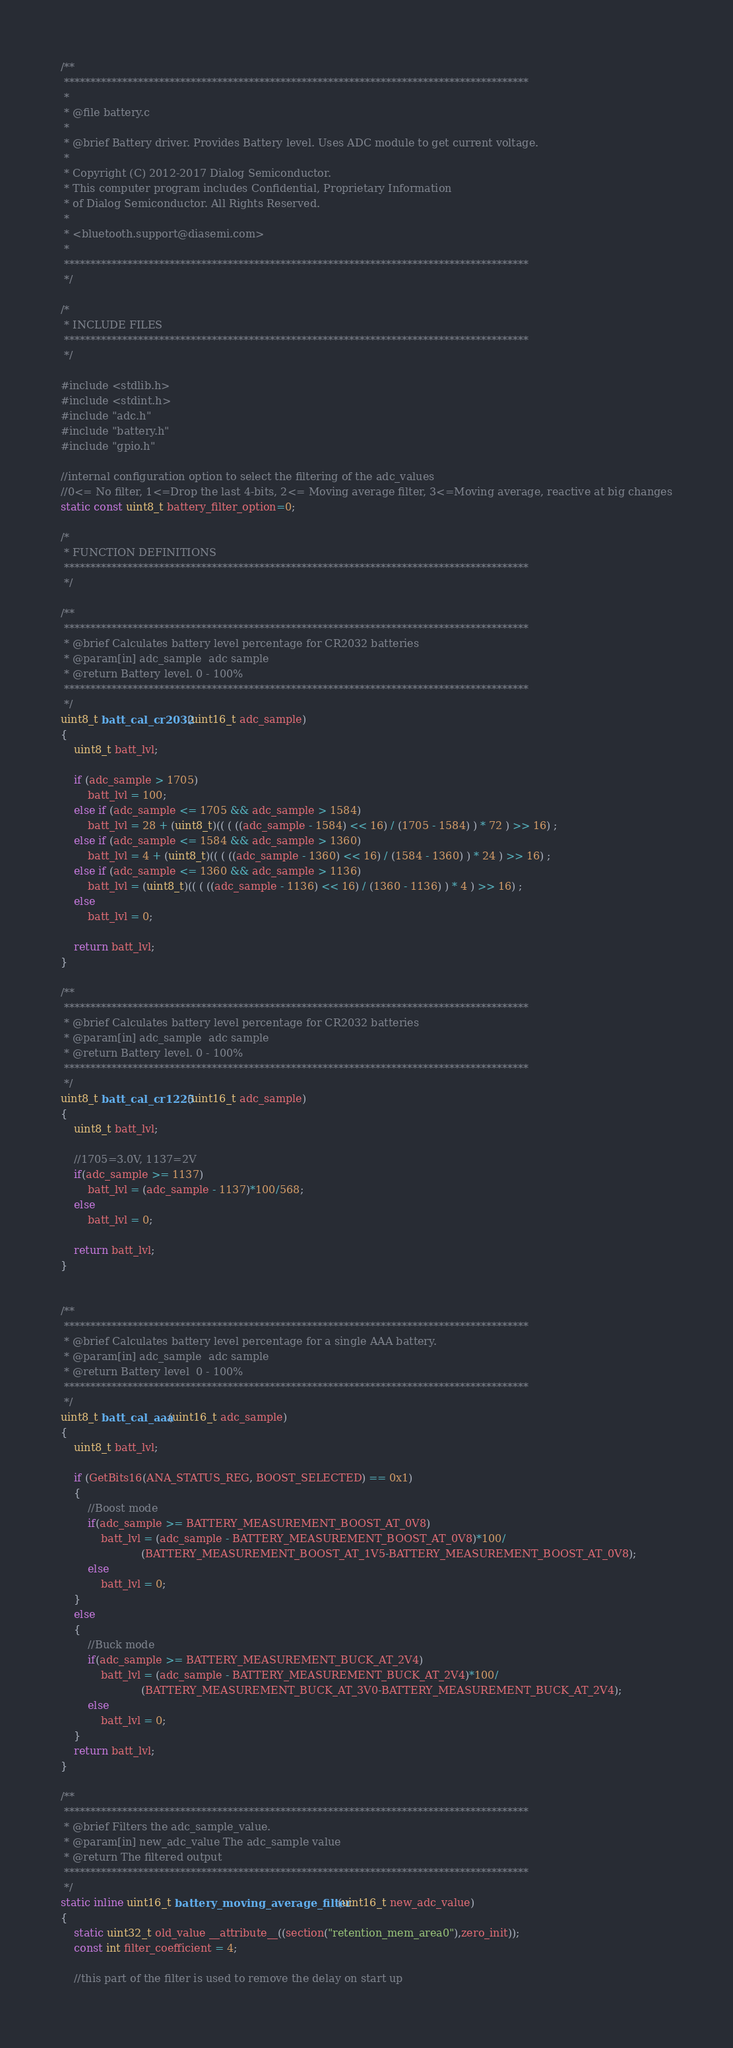<code> <loc_0><loc_0><loc_500><loc_500><_C_>/**
 ****************************************************************************************
 *
 * @file battery.c
 *
 * @brief Battery driver. Provides Battery level. Uses ADC module to get current voltage.
 *
 * Copyright (C) 2012-2017 Dialog Semiconductor.
 * This computer program includes Confidential, Proprietary Information
 * of Dialog Semiconductor. All Rights Reserved.
 *
 * <bluetooth.support@diasemi.com>
 *
 ****************************************************************************************
 */

/*
 * INCLUDE FILES
 ****************************************************************************************
 */

#include <stdlib.h>
#include <stdint.h>
#include "adc.h"
#include "battery.h"
#include "gpio.h"

//internal configuration option to select the filtering of the adc_values
//0<= No filter, 1<=Drop the last 4-bits, 2<= Moving average filter, 3<=Moving average, reactive at big changes
static const uint8_t battery_filter_option=0;

/*
 * FUNCTION DEFINITIONS
 ****************************************************************************************
 */

/**
 ****************************************************************************************
 * @brief Calculates battery level percentage for CR2032 batteries
 * @param[in] adc_sample  adc sample
 * @return Battery level. 0 - 100%
 ****************************************************************************************
 */
uint8_t batt_cal_cr2032(uint16_t adc_sample)
{
    uint8_t batt_lvl;

    if (adc_sample > 1705)
        batt_lvl = 100;
    else if (adc_sample <= 1705 && adc_sample > 1584)
        batt_lvl = 28 + (uint8_t)(( ( ((adc_sample - 1584) << 16) / (1705 - 1584) ) * 72 ) >> 16) ;
    else if (adc_sample <= 1584 && adc_sample > 1360)
        batt_lvl = 4 + (uint8_t)(( ( ((adc_sample - 1360) << 16) / (1584 - 1360) ) * 24 ) >> 16) ;
    else if (adc_sample <= 1360 && adc_sample > 1136)
        batt_lvl = (uint8_t)(( ( ((adc_sample - 1136) << 16) / (1360 - 1136) ) * 4 ) >> 16) ;
    else
        batt_lvl = 0;

    return batt_lvl;
}

/**
 ****************************************************************************************
 * @brief Calculates battery level percentage for CR2032 batteries
 * @param[in] adc_sample  adc sample
 * @return Battery level. 0 - 100%
 ****************************************************************************************
 */
uint8_t batt_cal_cr1225(uint16_t adc_sample)
{
    uint8_t batt_lvl;

    //1705=3.0V, 1137=2V
    if(adc_sample >= 1137)
        batt_lvl = (adc_sample - 1137)*100/568;
    else
        batt_lvl = 0;

    return batt_lvl;
}


/**
 ****************************************************************************************
 * @brief Calculates battery level percentage for a single AAA battery.
 * @param[in] adc_sample  adc sample
 * @return Battery level  0 - 100%
 ****************************************************************************************
 */
uint8_t batt_cal_aaa(uint16_t adc_sample)
{
    uint8_t batt_lvl;

    if (GetBits16(ANA_STATUS_REG, BOOST_SELECTED) == 0x1)
    {
        //Boost mode
        if(adc_sample >= BATTERY_MEASUREMENT_BOOST_AT_0V8)
            batt_lvl = (adc_sample - BATTERY_MEASUREMENT_BOOST_AT_0V8)*100/
                        (BATTERY_MEASUREMENT_BOOST_AT_1V5-BATTERY_MEASUREMENT_BOOST_AT_0V8);
        else
            batt_lvl = 0;
    }
    else
    {
        //Buck mode
        if(adc_sample >= BATTERY_MEASUREMENT_BUCK_AT_2V4)
            batt_lvl = (adc_sample - BATTERY_MEASUREMENT_BUCK_AT_2V4)*100/
                        (BATTERY_MEASUREMENT_BUCK_AT_3V0-BATTERY_MEASUREMENT_BUCK_AT_2V4);
        else
            batt_lvl = 0;
    }
    return batt_lvl;
}

/**
 ****************************************************************************************
 * @brief Filters the adc_sample_value.
 * @param[in] new_adc_value The adc_sample value
 * @return The filtered output
 ****************************************************************************************
 */
static inline uint16_t battery_moving_average_filter(uint16_t new_adc_value)
{
    static uint32_t old_value __attribute__((section("retention_mem_area0"),zero_init));
    const int filter_coefficient = 4;

    //this part of the filter is used to remove the delay on start up</code> 